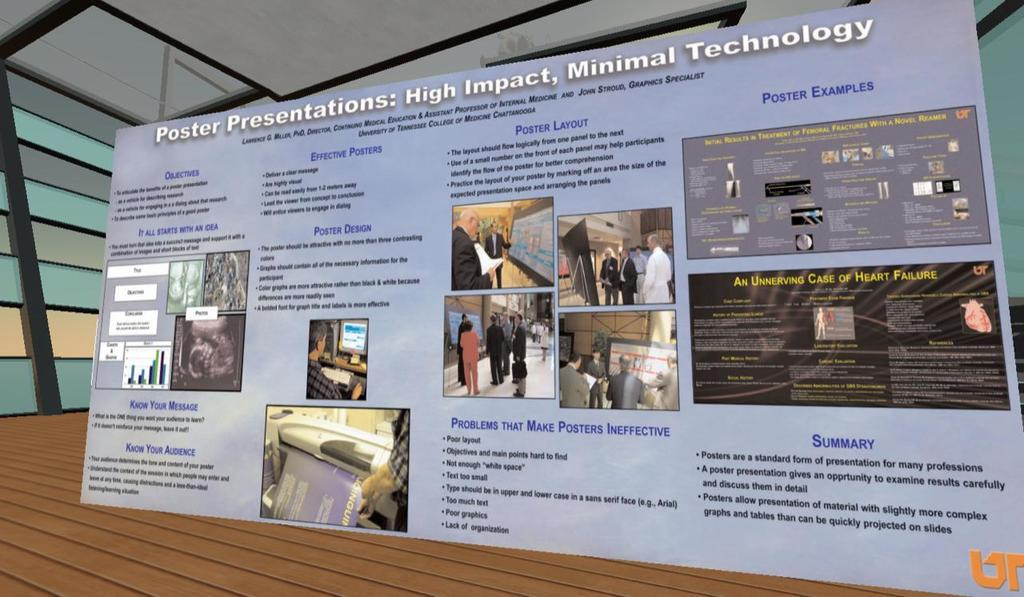<image>
Create a compact narrative representing the image presented. A poster supporting poster presentations lists the many benefits of that form of presentation. 